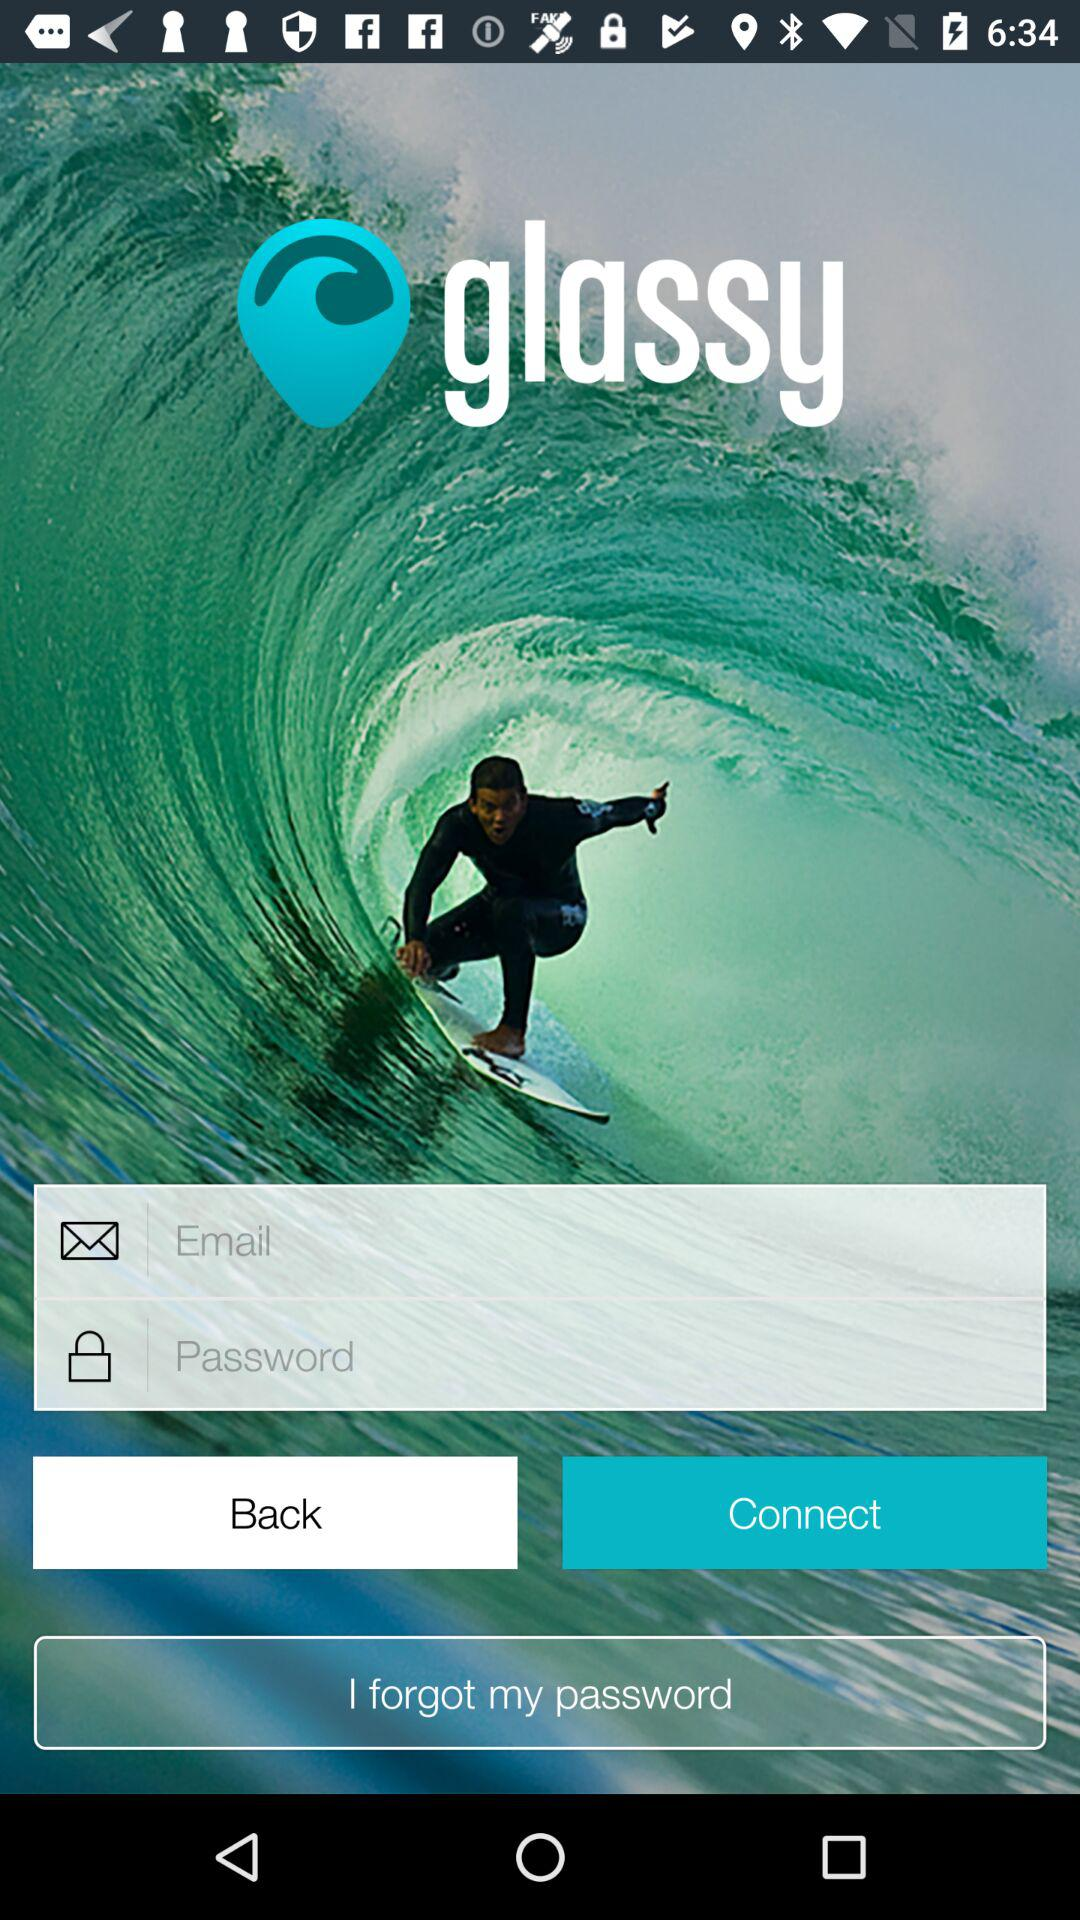How many inputs do you need to fill out to log in?
Answer the question using a single word or phrase. 2 